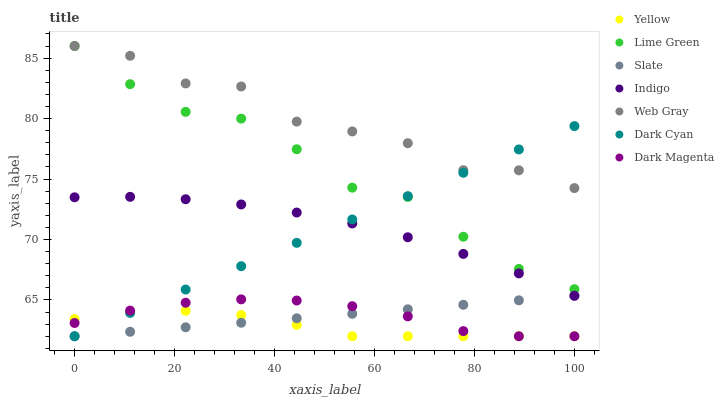Does Yellow have the minimum area under the curve?
Answer yes or no. Yes. Does Web Gray have the maximum area under the curve?
Answer yes or no. Yes. Does Indigo have the minimum area under the curve?
Answer yes or no. No. Does Indigo have the maximum area under the curve?
Answer yes or no. No. Is Slate the smoothest?
Answer yes or no. Yes. Is Web Gray the roughest?
Answer yes or no. Yes. Is Indigo the smoothest?
Answer yes or no. No. Is Indigo the roughest?
Answer yes or no. No. Does Dark Magenta have the lowest value?
Answer yes or no. Yes. Does Indigo have the lowest value?
Answer yes or no. No. Does Lime Green have the highest value?
Answer yes or no. Yes. Does Indigo have the highest value?
Answer yes or no. No. Is Slate less than Lime Green?
Answer yes or no. Yes. Is Indigo greater than Dark Magenta?
Answer yes or no. Yes. Does Yellow intersect Slate?
Answer yes or no. Yes. Is Yellow less than Slate?
Answer yes or no. No. Is Yellow greater than Slate?
Answer yes or no. No. Does Slate intersect Lime Green?
Answer yes or no. No. 